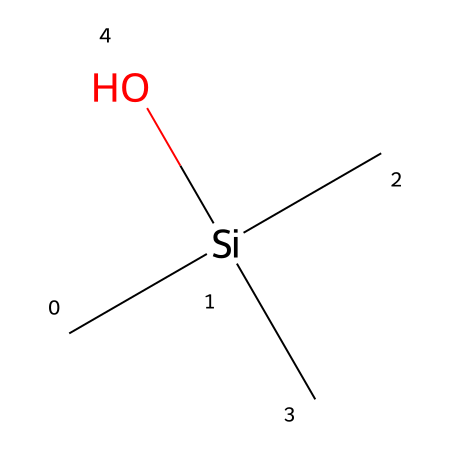What is the molecular formula of trimethylsilanol? The molecular formula can be derived from the SMILES representation, where 'C' represents carbon and 'Si' represents silicon. There are three 'C' in the trimethyl group and one 'Si' along with one oxygen 'O', leading to the formula: C3H10OSi.
Answer: C3H10OSi How many carbon atoms are present in trimethylsilanol? By analyzing the SMILES, we see three 'C' symbols, indicating there are three carbon atoms in the molecule.
Answer: 3 What type of bonds are present in trimethylsilanol? The SMILES structure indicates that there are single bonds between the silicon and the three carbon atoms, and also a single bond between the silicon and the oxygen. This suggests that the primary type of bonds present in this compound are sigma bonds.
Answer: sigma bonds What functional group is indicated in trimethylsilanol? The presence of the hydroxyl group (–OH) attached to silicon points to the functional group being an alcohol.
Answer: alcohol How many hydrogen atoms are bound to the silicon atom? In the structure, the silicon atom is connected to three methyl groups (each contributing one hydrogen atom) and it does not directly bond any additional hydrogen, meaning there are three hydrogen atoms directly associated with silicon.'
Answer: 3 Is trimethylsilanol a primary or tertiary alcohol? Since the –OH group is attached to a silicon atom bonded to three other carbon atoms (making it tertiary), it classifies trimethylsilanol as a tertiary alcohol.
Answer: tertiary 